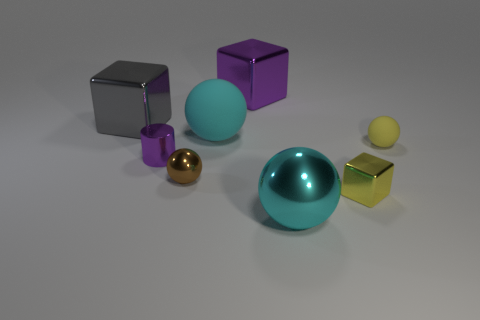There is a yellow object that is the same shape as the gray metallic thing; what is its size?
Make the answer very short. Small. Do the big cube that is behind the gray metallic block and the tiny shiny cylinder that is behind the yellow metal cube have the same color?
Your answer should be compact. Yes. Are there any purple metallic things of the same shape as the large gray thing?
Provide a succinct answer. Yes. What is the material of the small yellow block?
Provide a succinct answer. Metal. What size is the metallic ball left of the cyan object that is to the right of the large metallic cube behind the gray metal thing?
Offer a terse response. Small. What material is the thing that is the same color as the cylinder?
Offer a very short reply. Metal. What number of metallic things are either gray objects or cyan balls?
Offer a terse response. 2. What size is the yellow shiny cube?
Your response must be concise. Small. How many things are big purple things or large cubes on the right side of the big cyan matte ball?
Ensure brevity in your answer.  1. How many other objects are the same color as the tiny shiny cylinder?
Your answer should be very brief. 1. 